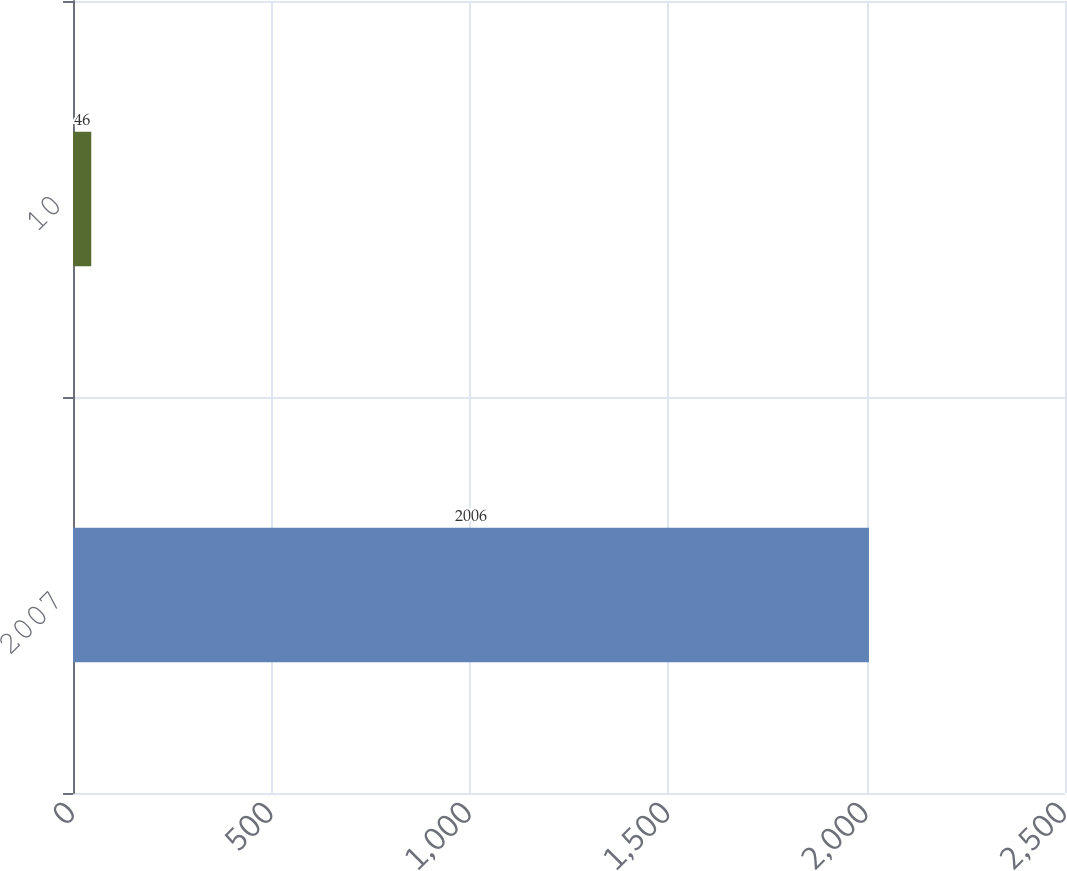Convert chart to OTSL. <chart><loc_0><loc_0><loc_500><loc_500><bar_chart><fcel>2007<fcel>10<nl><fcel>2006<fcel>46<nl></chart> 